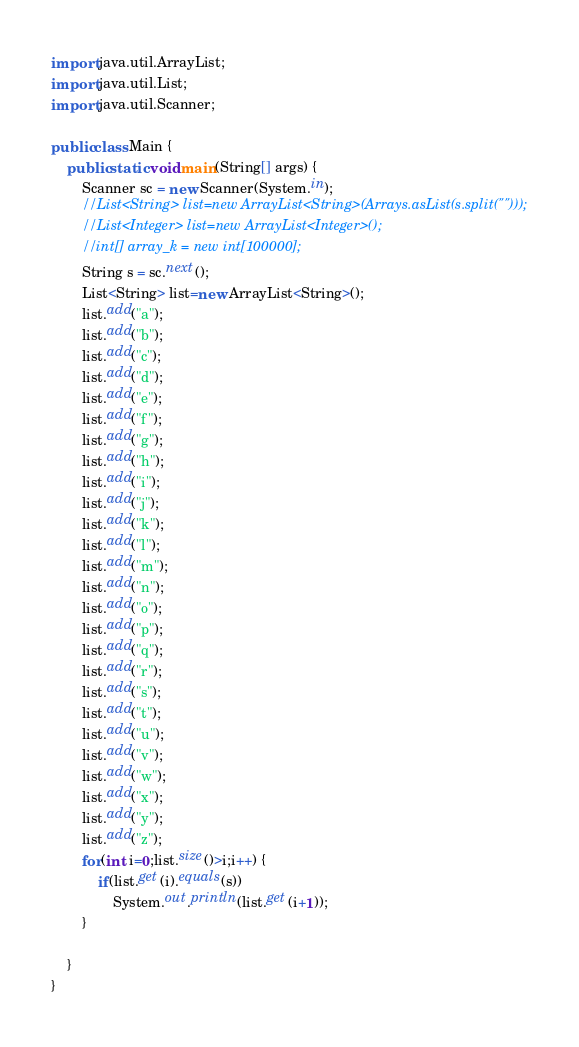Convert code to text. <code><loc_0><loc_0><loc_500><loc_500><_Java_>import java.util.ArrayList;
import java.util.List;
import java.util.Scanner;

public class Main {
	public static void main(String[] args) {
		Scanner sc = new Scanner(System.in);
		//List<String> list=new ArrayList<String>(Arrays.asList(s.split("")));
		//List<Integer> list=new ArrayList<Integer>();
		//int[] array_k = new int[100000];
		String s = sc.next();
		List<String> list=new ArrayList<String>();
		list.add("a");
		list.add("b");
		list.add("c");
		list.add("d");
		list.add("e");
		list.add("f");
		list.add("g");
		list.add("h");
		list.add("i");
		list.add("j");
		list.add("k");
		list.add("l");
		list.add("m");
		list.add("n");
		list.add("o");
		list.add("p");
		list.add("q");
		list.add("r");
		list.add("s");
		list.add("t");
		list.add("u");
		list.add("v");
		list.add("w");
		list.add("x");
		list.add("y");
		list.add("z");
		for(int i=0;list.size()>i;i++) {
			if(list.get(i).equals(s))
				System.out.println(list.get(i+1));
		}

	}
}</code> 